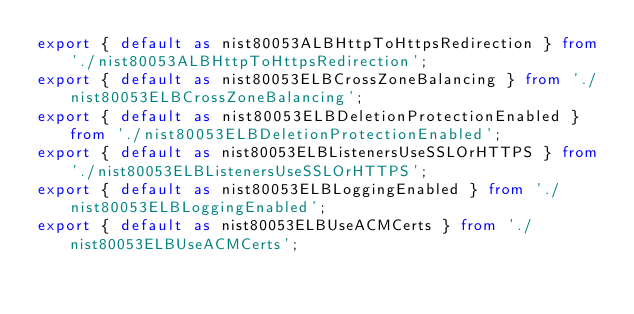Convert code to text. <code><loc_0><loc_0><loc_500><loc_500><_TypeScript_>export { default as nist80053ALBHttpToHttpsRedirection } from './nist80053ALBHttpToHttpsRedirection';
export { default as nist80053ELBCrossZoneBalancing } from './nist80053ELBCrossZoneBalancing';
export { default as nist80053ELBDeletionProtectionEnabled } from './nist80053ELBDeletionProtectionEnabled';
export { default as nist80053ELBListenersUseSSLOrHTTPS } from './nist80053ELBListenersUseSSLOrHTTPS';
export { default as nist80053ELBLoggingEnabled } from './nist80053ELBLoggingEnabled';
export { default as nist80053ELBUseACMCerts } from './nist80053ELBUseACMCerts';
</code> 